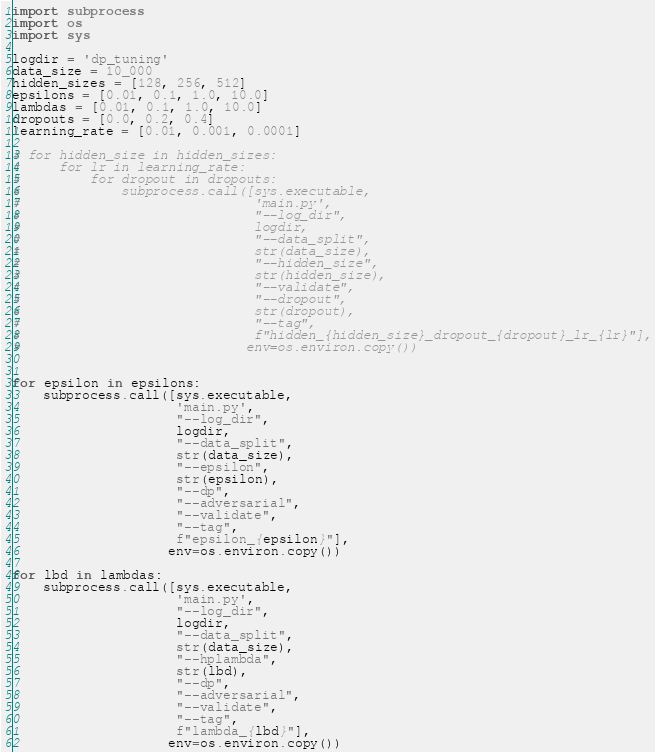Convert code to text. <code><loc_0><loc_0><loc_500><loc_500><_Python_>import subprocess
import os
import sys

logdir = 'dp_tuning'
data_size = 10_000
hidden_sizes = [128, 256, 512]
epsilons = [0.01, 0.1, 1.0, 10.0]
lambdas = [0.01, 0.1, 1.0, 10.0]
dropouts = [0.0, 0.2, 0.4]
learning_rate = [0.01, 0.001, 0.0001]

# for hidden_size in hidden_sizes:
#     for lr in learning_rate:
#         for dropout in dropouts:
#             subprocess.call([sys.executable,
#                              'main.py',
#                              "--log_dir",
#                              logdir,
#                              "--data_split",
#                              str(data_size),
#                              "--hidden_size",
#                              str(hidden_size),
#                              "--validate",
#                              "--dropout",
#                              str(dropout),
#                              "--tag",
#                              f"hidden_{hidden_size}_dropout_{dropout}_lr_{lr}"],
#                             env=os.environ.copy())


for epsilon in epsilons:
    subprocess.call([sys.executable,
                     'main.py',
                     "--log_dir",
                     logdir,
                     "--data_split",
                     str(data_size),
                     "--epsilon",
                     str(epsilon),
                     "--dp",
                     "--adversarial",
                     "--validate",
                     "--tag",
                     f"epsilon_{epsilon}"],
                    env=os.environ.copy())

for lbd in lambdas:
    subprocess.call([sys.executable,
                     'main.py',
                     "--log_dir",
                     logdir,
                     "--data_split",
                     str(data_size),
                     "--hplambda",
                     str(lbd),
                     "--dp",
                     "--adversarial",
                     "--validate",
                     "--tag",
                     f"lambda_{lbd}"],
                    env=os.environ.copy())
</code> 